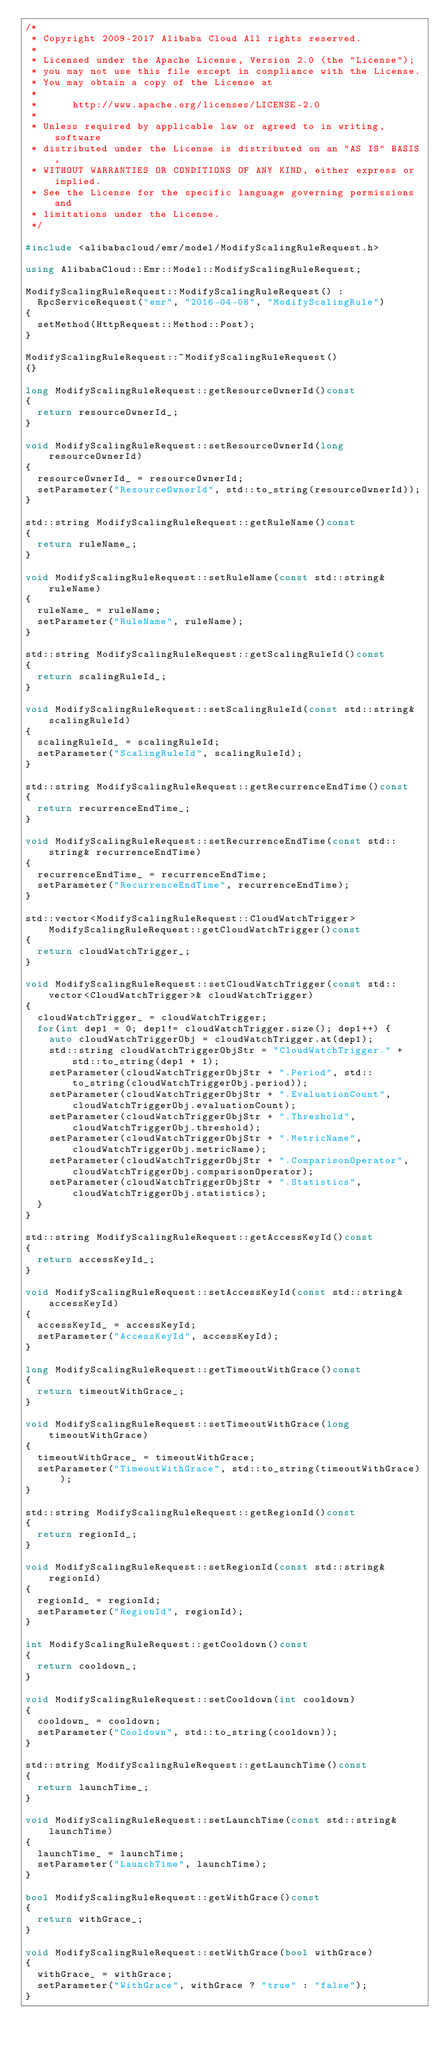<code> <loc_0><loc_0><loc_500><loc_500><_C++_>/*
 * Copyright 2009-2017 Alibaba Cloud All rights reserved.
 * 
 * Licensed under the Apache License, Version 2.0 (the "License");
 * you may not use this file except in compliance with the License.
 * You may obtain a copy of the License at
 * 
 *      http://www.apache.org/licenses/LICENSE-2.0
 * 
 * Unless required by applicable law or agreed to in writing, software
 * distributed under the License is distributed on an "AS IS" BASIS,
 * WITHOUT WARRANTIES OR CONDITIONS OF ANY KIND, either express or implied.
 * See the License for the specific language governing permissions and
 * limitations under the License.
 */

#include <alibabacloud/emr/model/ModifyScalingRuleRequest.h>

using AlibabaCloud::Emr::Model::ModifyScalingRuleRequest;

ModifyScalingRuleRequest::ModifyScalingRuleRequest() :
	RpcServiceRequest("emr", "2016-04-08", "ModifyScalingRule")
{
	setMethod(HttpRequest::Method::Post);
}

ModifyScalingRuleRequest::~ModifyScalingRuleRequest()
{}

long ModifyScalingRuleRequest::getResourceOwnerId()const
{
	return resourceOwnerId_;
}

void ModifyScalingRuleRequest::setResourceOwnerId(long resourceOwnerId)
{
	resourceOwnerId_ = resourceOwnerId;
	setParameter("ResourceOwnerId", std::to_string(resourceOwnerId));
}

std::string ModifyScalingRuleRequest::getRuleName()const
{
	return ruleName_;
}

void ModifyScalingRuleRequest::setRuleName(const std::string& ruleName)
{
	ruleName_ = ruleName;
	setParameter("RuleName", ruleName);
}

std::string ModifyScalingRuleRequest::getScalingRuleId()const
{
	return scalingRuleId_;
}

void ModifyScalingRuleRequest::setScalingRuleId(const std::string& scalingRuleId)
{
	scalingRuleId_ = scalingRuleId;
	setParameter("ScalingRuleId", scalingRuleId);
}

std::string ModifyScalingRuleRequest::getRecurrenceEndTime()const
{
	return recurrenceEndTime_;
}

void ModifyScalingRuleRequest::setRecurrenceEndTime(const std::string& recurrenceEndTime)
{
	recurrenceEndTime_ = recurrenceEndTime;
	setParameter("RecurrenceEndTime", recurrenceEndTime);
}

std::vector<ModifyScalingRuleRequest::CloudWatchTrigger> ModifyScalingRuleRequest::getCloudWatchTrigger()const
{
	return cloudWatchTrigger_;
}

void ModifyScalingRuleRequest::setCloudWatchTrigger(const std::vector<CloudWatchTrigger>& cloudWatchTrigger)
{
	cloudWatchTrigger_ = cloudWatchTrigger;
	for(int dep1 = 0; dep1!= cloudWatchTrigger.size(); dep1++) {
		auto cloudWatchTriggerObj = cloudWatchTrigger.at(dep1);
		std::string cloudWatchTriggerObjStr = "CloudWatchTrigger." + std::to_string(dep1 + 1);
		setParameter(cloudWatchTriggerObjStr + ".Period", std::to_string(cloudWatchTriggerObj.period));
		setParameter(cloudWatchTriggerObjStr + ".EvaluationCount", cloudWatchTriggerObj.evaluationCount);
		setParameter(cloudWatchTriggerObjStr + ".Threshold", cloudWatchTriggerObj.threshold);
		setParameter(cloudWatchTriggerObjStr + ".MetricName", cloudWatchTriggerObj.metricName);
		setParameter(cloudWatchTriggerObjStr + ".ComparisonOperator", cloudWatchTriggerObj.comparisonOperator);
		setParameter(cloudWatchTriggerObjStr + ".Statistics", cloudWatchTriggerObj.statistics);
	}
}

std::string ModifyScalingRuleRequest::getAccessKeyId()const
{
	return accessKeyId_;
}

void ModifyScalingRuleRequest::setAccessKeyId(const std::string& accessKeyId)
{
	accessKeyId_ = accessKeyId;
	setParameter("AccessKeyId", accessKeyId);
}

long ModifyScalingRuleRequest::getTimeoutWithGrace()const
{
	return timeoutWithGrace_;
}

void ModifyScalingRuleRequest::setTimeoutWithGrace(long timeoutWithGrace)
{
	timeoutWithGrace_ = timeoutWithGrace;
	setParameter("TimeoutWithGrace", std::to_string(timeoutWithGrace));
}

std::string ModifyScalingRuleRequest::getRegionId()const
{
	return regionId_;
}

void ModifyScalingRuleRequest::setRegionId(const std::string& regionId)
{
	regionId_ = regionId;
	setParameter("RegionId", regionId);
}

int ModifyScalingRuleRequest::getCooldown()const
{
	return cooldown_;
}

void ModifyScalingRuleRequest::setCooldown(int cooldown)
{
	cooldown_ = cooldown;
	setParameter("Cooldown", std::to_string(cooldown));
}

std::string ModifyScalingRuleRequest::getLaunchTime()const
{
	return launchTime_;
}

void ModifyScalingRuleRequest::setLaunchTime(const std::string& launchTime)
{
	launchTime_ = launchTime;
	setParameter("LaunchTime", launchTime);
}

bool ModifyScalingRuleRequest::getWithGrace()const
{
	return withGrace_;
}

void ModifyScalingRuleRequest::setWithGrace(bool withGrace)
{
	withGrace_ = withGrace;
	setParameter("WithGrace", withGrace ? "true" : "false");
}
</code> 